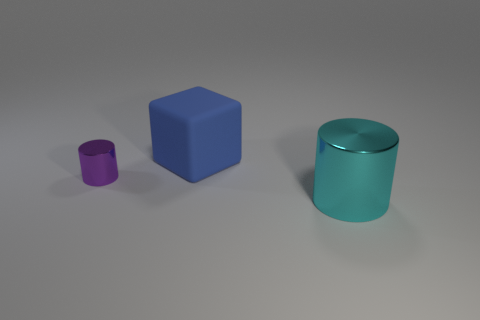Add 2 small purple objects. How many objects exist? 5 Subtract all cubes. How many objects are left? 2 Subtract all matte cylinders. Subtract all matte blocks. How many objects are left? 2 Add 3 large cyan shiny things. How many large cyan shiny things are left? 4 Add 1 balls. How many balls exist? 1 Subtract 1 cyan cylinders. How many objects are left? 2 Subtract 1 cylinders. How many cylinders are left? 1 Subtract all gray cubes. Subtract all green balls. How many cubes are left? 1 Subtract all gray cubes. How many cyan cylinders are left? 1 